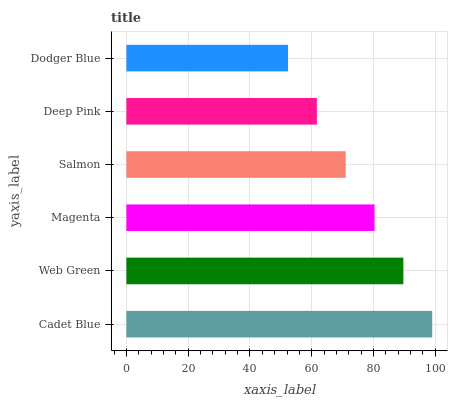Is Dodger Blue the minimum?
Answer yes or no. Yes. Is Cadet Blue the maximum?
Answer yes or no. Yes. Is Web Green the minimum?
Answer yes or no. No. Is Web Green the maximum?
Answer yes or no. No. Is Cadet Blue greater than Web Green?
Answer yes or no. Yes. Is Web Green less than Cadet Blue?
Answer yes or no. Yes. Is Web Green greater than Cadet Blue?
Answer yes or no. No. Is Cadet Blue less than Web Green?
Answer yes or no. No. Is Magenta the high median?
Answer yes or no. Yes. Is Salmon the low median?
Answer yes or no. Yes. Is Web Green the high median?
Answer yes or no. No. Is Deep Pink the low median?
Answer yes or no. No. 